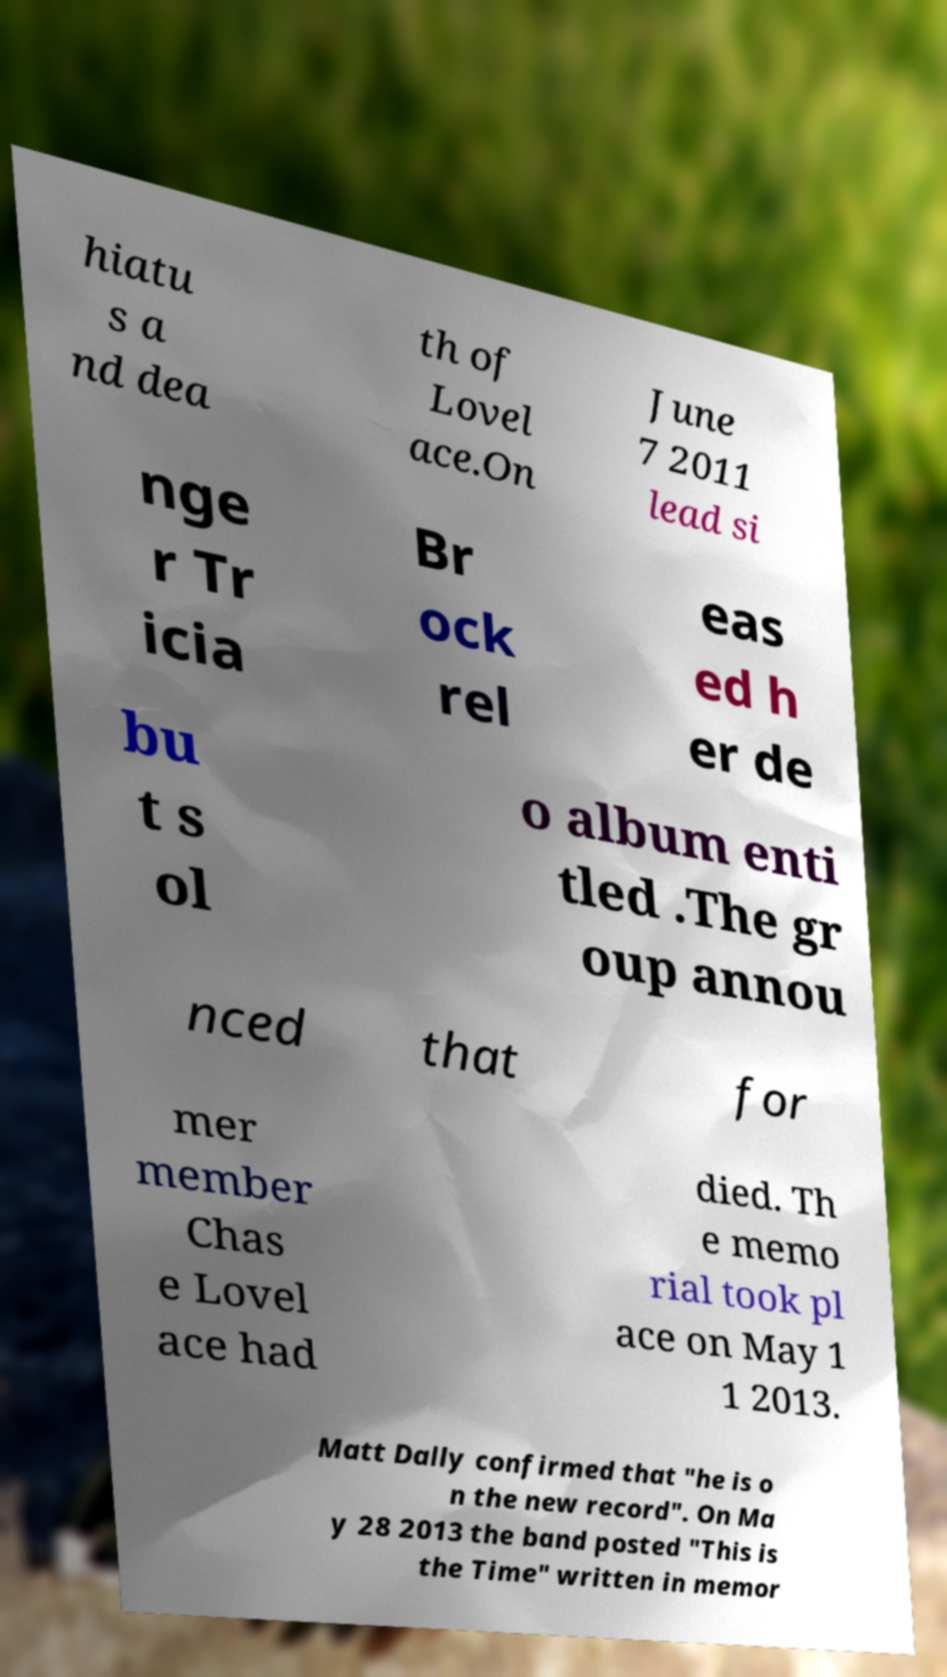Please read and relay the text visible in this image. What does it say? hiatu s a nd dea th of Lovel ace.On June 7 2011 lead si nge r Tr icia Br ock rel eas ed h er de bu t s ol o album enti tled .The gr oup annou nced that for mer member Chas e Lovel ace had died. Th e memo rial took pl ace on May 1 1 2013. Matt Dally confirmed that "he is o n the new record". On Ma y 28 2013 the band posted "This is the Time" written in memor 